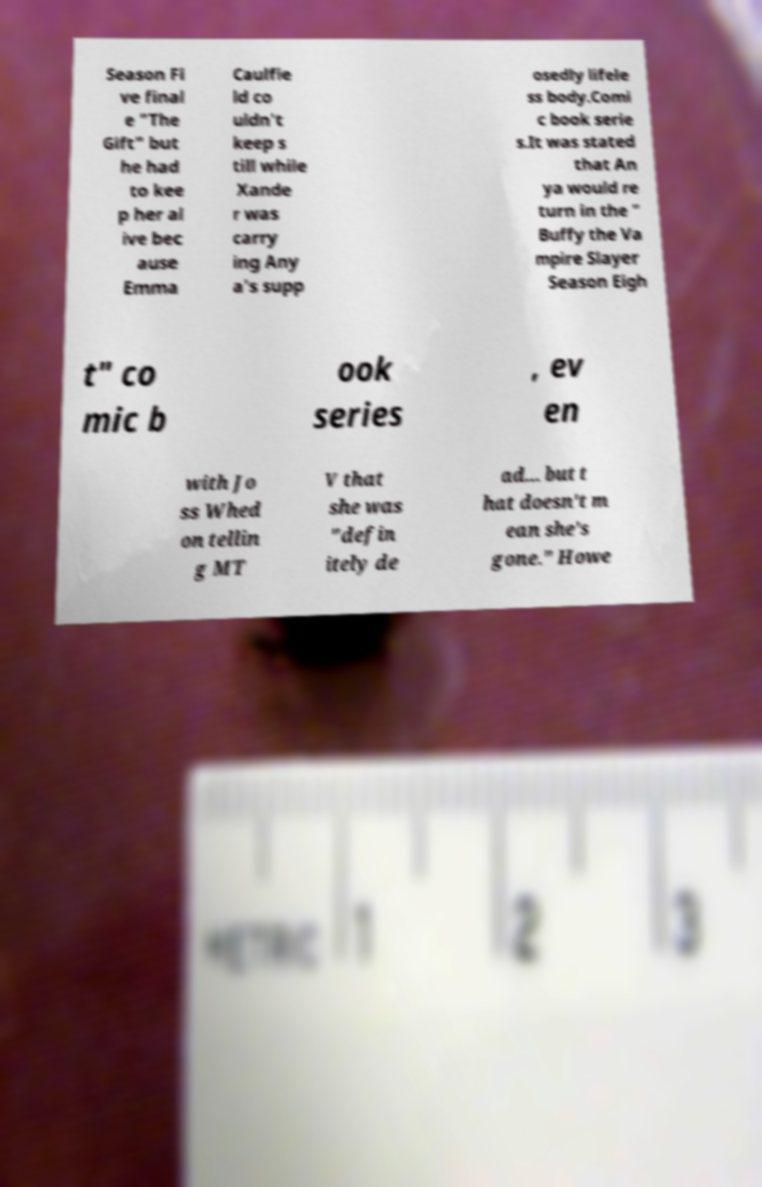Can you accurately transcribe the text from the provided image for me? Season Fi ve final e "The Gift" but he had to kee p her al ive bec ause Emma Caulfie ld co uldn't keep s till while Xande r was carry ing Any a's supp osedly lifele ss body.Comi c book serie s.It was stated that An ya would re turn in the " Buffy the Va mpire Slayer Season Eigh t" co mic b ook series , ev en with Jo ss Whed on tellin g MT V that she was "defin itely de ad... but t hat doesn't m ean she's gone." Howe 